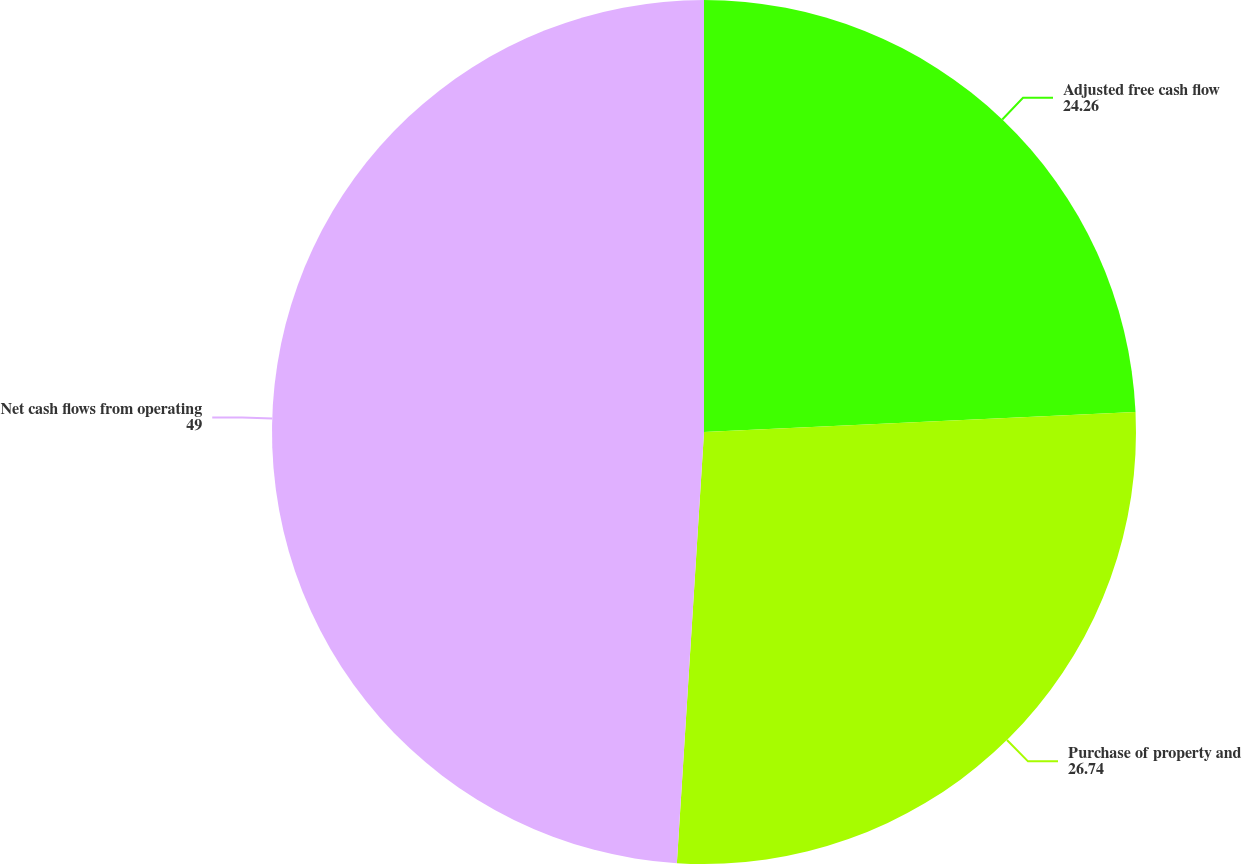<chart> <loc_0><loc_0><loc_500><loc_500><pie_chart><fcel>Adjusted free cash flow<fcel>Purchase of property and<fcel>Net cash flows from operating<nl><fcel>24.26%<fcel>26.74%<fcel>49.0%<nl></chart> 